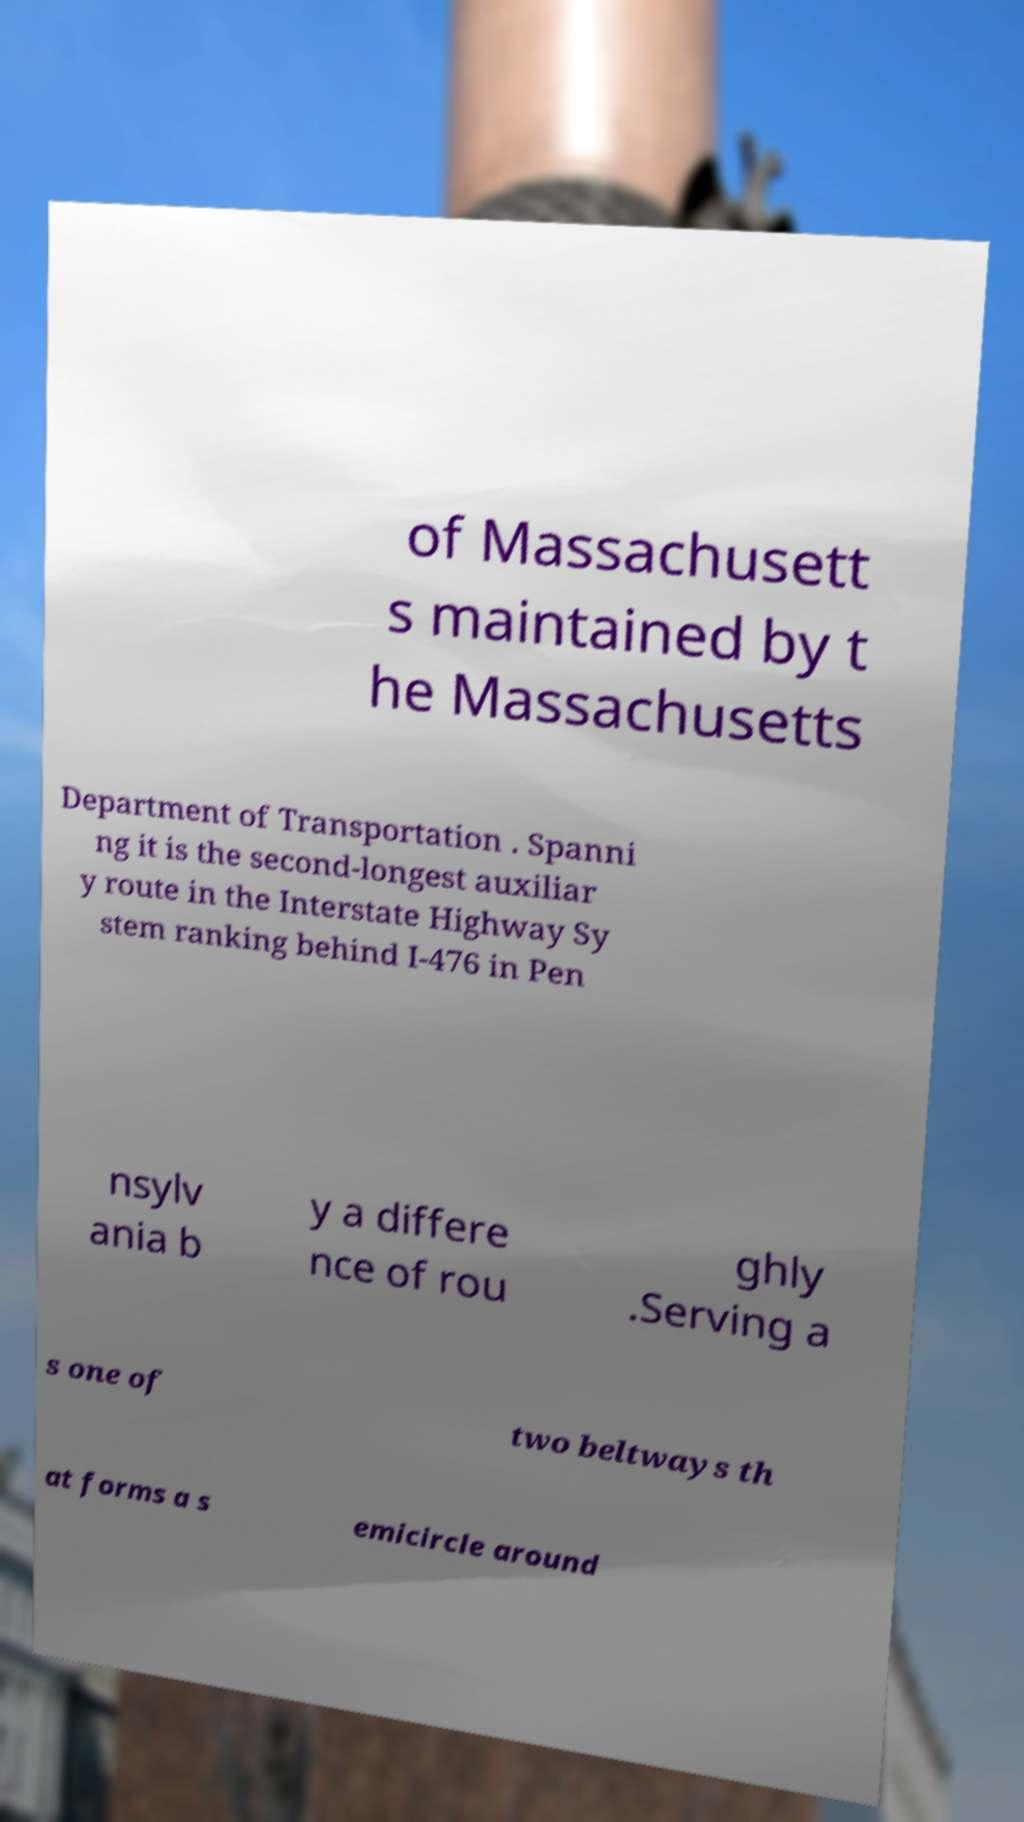Could you extract and type out the text from this image? of Massachusett s maintained by t he Massachusetts Department of Transportation . Spanni ng it is the second-longest auxiliar y route in the Interstate Highway Sy stem ranking behind I-476 in Pen nsylv ania b y a differe nce of rou ghly .Serving a s one of two beltways th at forms a s emicircle around 